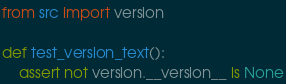Convert code to text. <code><loc_0><loc_0><loc_500><loc_500><_Python_>from src import version

def test_version_text():
    assert not version.__version__ is None</code> 